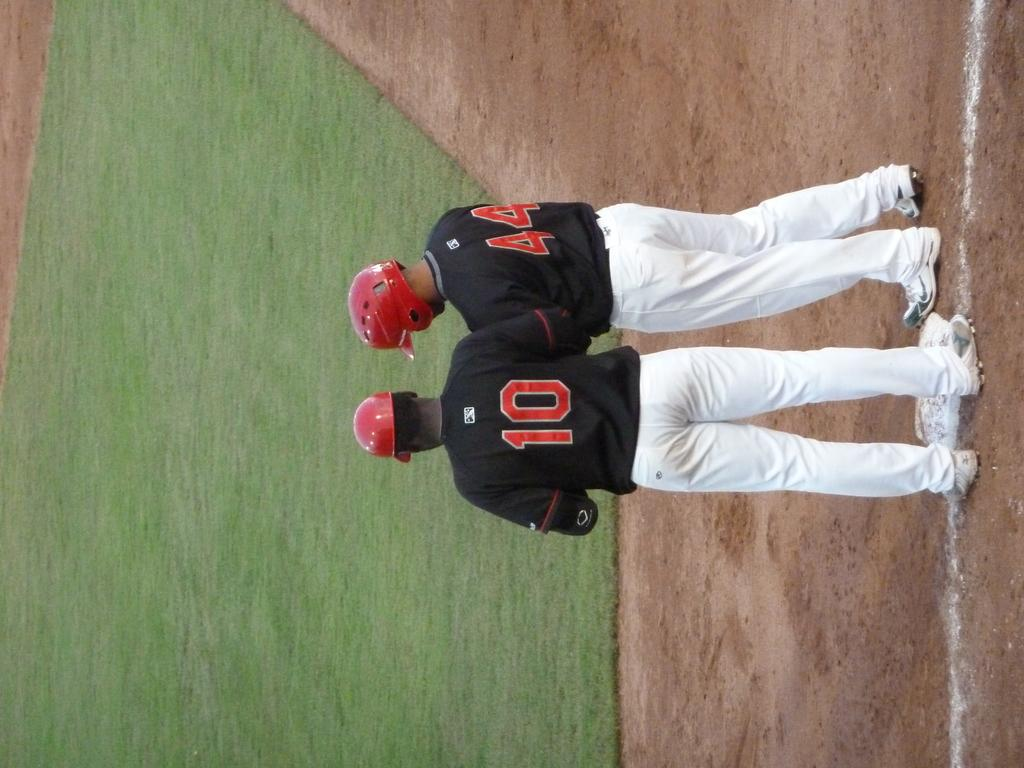<image>
Present a compact description of the photo's key features. Players in the number 10 and number 44 jerseys stand together at a base. 